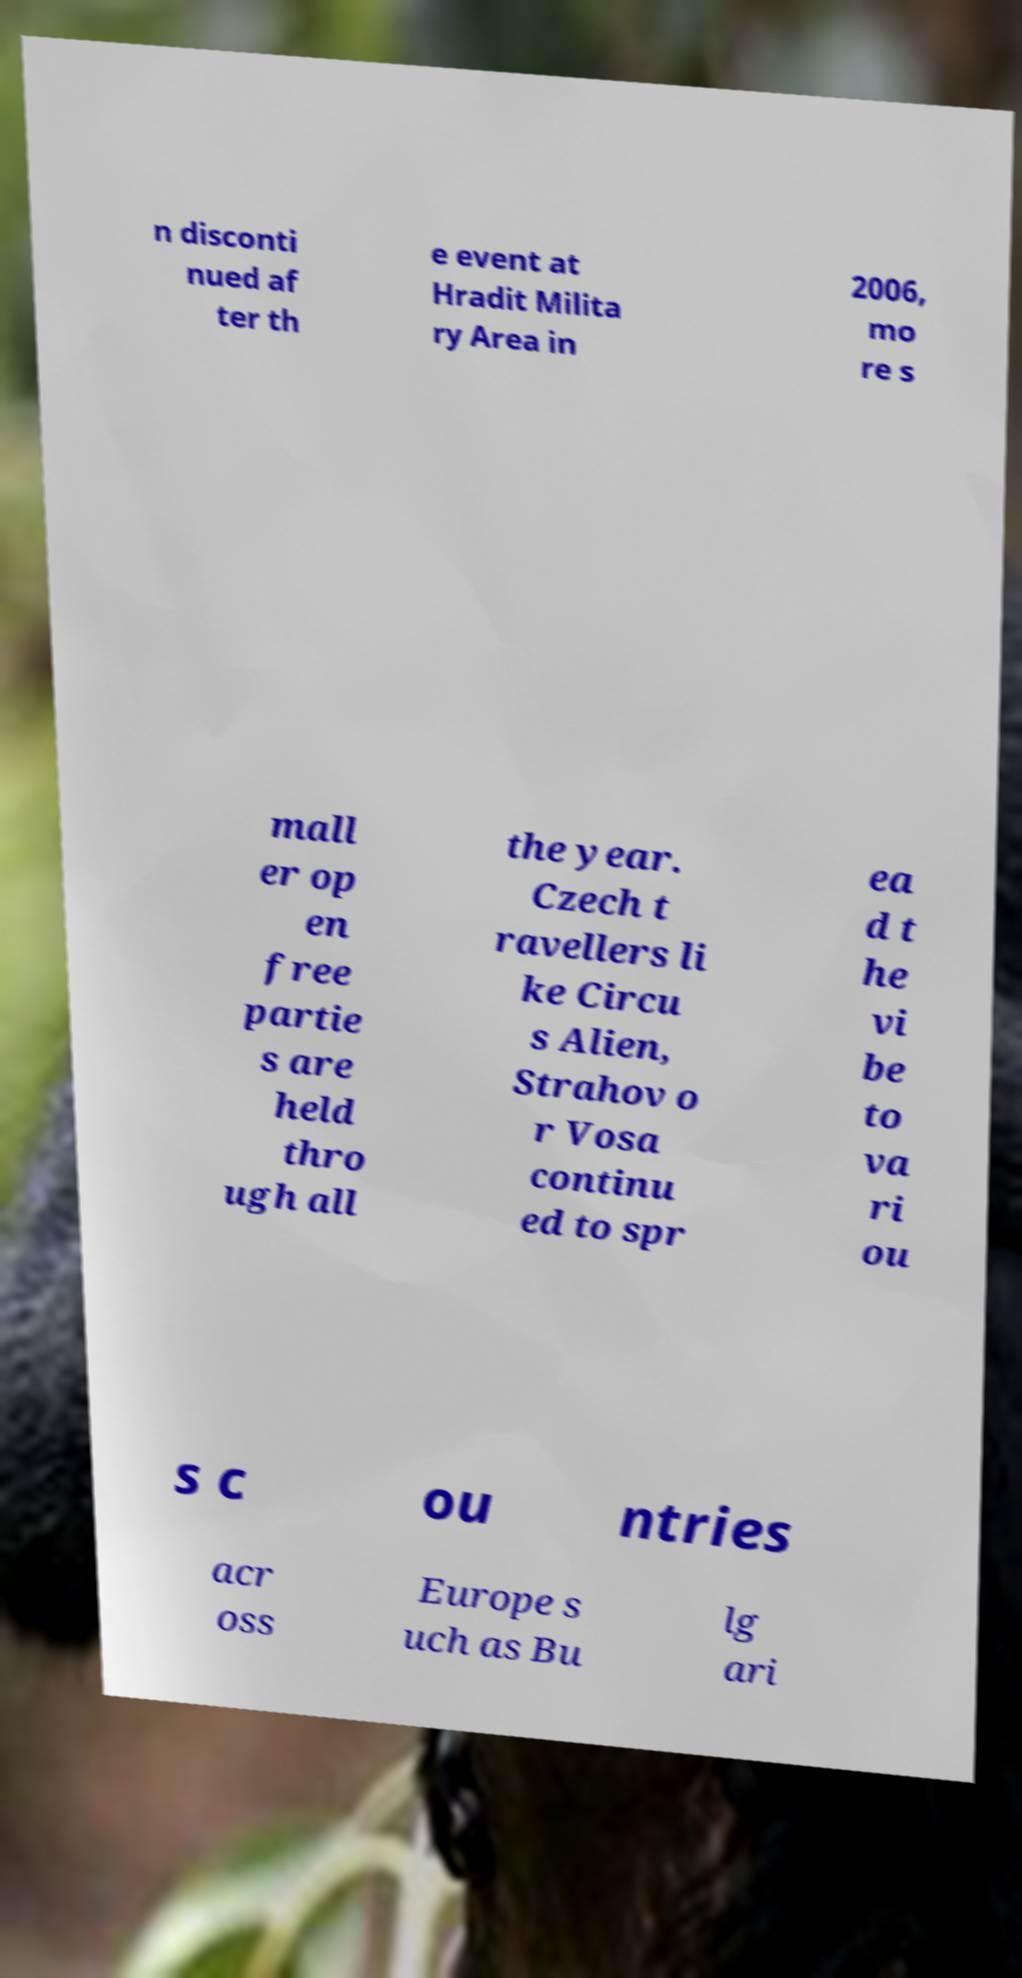Please read and relay the text visible in this image. What does it say? n disconti nued af ter th e event at Hradit Milita ry Area in 2006, mo re s mall er op en free partie s are held thro ugh all the year. Czech t ravellers li ke Circu s Alien, Strahov o r Vosa continu ed to spr ea d t he vi be to va ri ou s c ou ntries acr oss Europe s uch as Bu lg ari 